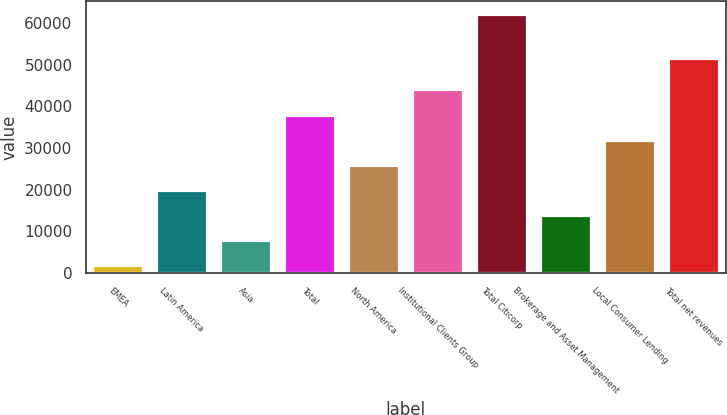Convert chart to OTSL. <chart><loc_0><loc_0><loc_500><loc_500><bar_chart><fcel>EMEA<fcel>Latin America<fcel>Asia<fcel>Total<fcel>North America<fcel>Institutional Clients Group<fcel>Total Citicorp<fcel>Brokerage and Asset Management<fcel>Local Consumer Lending<fcel>Total net revenues<nl><fcel>1865<fcel>19934<fcel>7888<fcel>38003<fcel>25957<fcel>44026<fcel>62095<fcel>13911<fcel>31980<fcel>51599<nl></chart> 